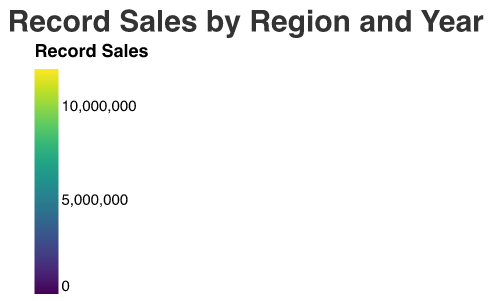What's the title of the figure? The title is written at the top of the figure and is usually in a larger font size to indicate its importance.
Answer: Record Sales by Region and Year Which artist had the highest sales in North America in 1980? Look at the heatmap for the North America row and 1980 column, check which artist has the darkest color indicating the highest sales.
Answer: Elvis Presley How did Julio Iglesias' sales in Europe change from 1980 to 1990? Compare the color shades of Julio Iglesias in the Europe region for 1980 and 1990, check which year has the darker shade indicating higher sales.
Answer: Increased Which region had the highest sales for Frank Sinatra in 2000? Refer to the 2000 column and find the region row for Frank Sinatra that has the darkest color.
Answer: Europe Between Michael Jackson and Madonna, who had higher sales in Asia in 2010? Compare the color shades of Michael Jackson and Madonna in the Asia region for 2010, darker shades indicate higher sales.
Answer: Madonna Calculate the total sales of Julio Iglesias in 1990 across all regions. Sum up the sales values for Julio Iglesias in all regions (North America, Latin America, Europe, Asia) for 1990.
Answer: 12,500,000 Which artist showed a decrease in sales from 1980 to 2010 in North America? Compare the color shades from 1980 to 2010 in the North America region for each artist. Look for artists who have lighter shades in 2010.
Answer: Frank Sinatra How do Madonna's sales in Europe compare to her sales in Latin America in 2010? Compare the color shades for Madonna in the Europe and Latin America regions in 2010, the darker shade indicates higher sales.
Answer: Higher in Europe How did Elvis Presley's sales change in Latin America from 1980 to 2000? Compare the color shades for Elvis Presley in Latin America across 1980 and 2000.
Answer: Decreased What is the average sales of Michael Jackson in Asia across all years? Sum up Michael Jackson's sales in Asia for 1980, 1990, 2000, and 2010, then divide by 4 (the number of years).
Answer: 2,075,000 